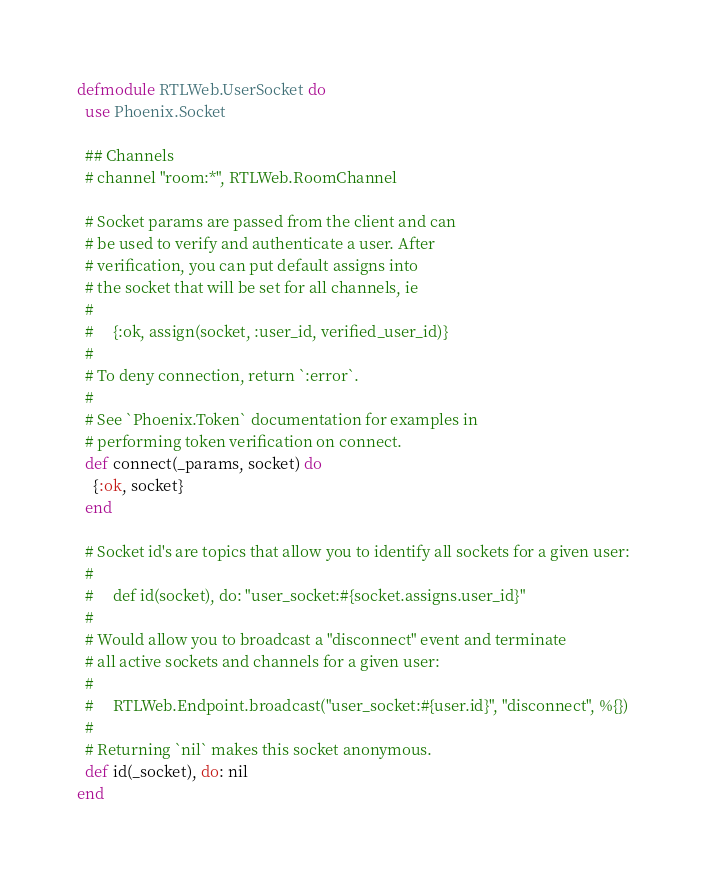<code> <loc_0><loc_0><loc_500><loc_500><_Elixir_>defmodule RTLWeb.UserSocket do
  use Phoenix.Socket

  ## Channels
  # channel "room:*", RTLWeb.RoomChannel

  # Socket params are passed from the client and can
  # be used to verify and authenticate a user. After
  # verification, you can put default assigns into
  # the socket that will be set for all channels, ie
  #
  #     {:ok, assign(socket, :user_id, verified_user_id)}
  #
  # To deny connection, return `:error`.
  #
  # See `Phoenix.Token` documentation for examples in
  # performing token verification on connect.
  def connect(_params, socket) do
    {:ok, socket}
  end

  # Socket id's are topics that allow you to identify all sockets for a given user:
  #
  #     def id(socket), do: "user_socket:#{socket.assigns.user_id}"
  #
  # Would allow you to broadcast a "disconnect" event and terminate
  # all active sockets and channels for a given user:
  #
  #     RTLWeb.Endpoint.broadcast("user_socket:#{user.id}", "disconnect", %{})
  #
  # Returning `nil` makes this socket anonymous.
  def id(_socket), do: nil
end
</code> 